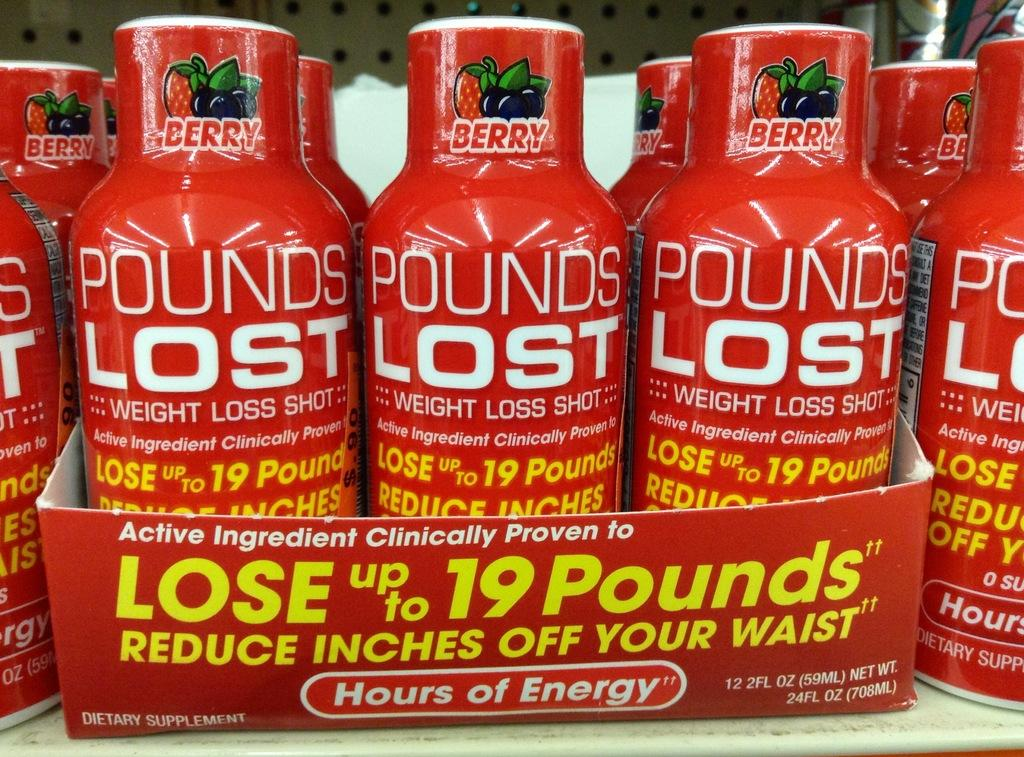<image>
Write a terse but informative summary of the picture. A display for Pounds Lost weight loss shots is red. 